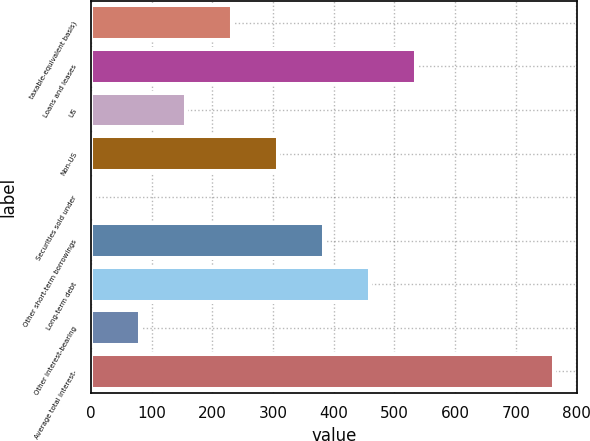Convert chart. <chart><loc_0><loc_0><loc_500><loc_500><bar_chart><fcel>taxable-equivalent basis)<fcel>Loans and leases<fcel>US<fcel>Non-US<fcel>Securities sold under<fcel>Other short-term borrowings<fcel>Long-term debt<fcel>Other interest-bearing<fcel>Average total interest-<nl><fcel>231.7<fcel>535.3<fcel>155.8<fcel>307.6<fcel>4<fcel>383.5<fcel>459.4<fcel>79.9<fcel>763<nl></chart> 